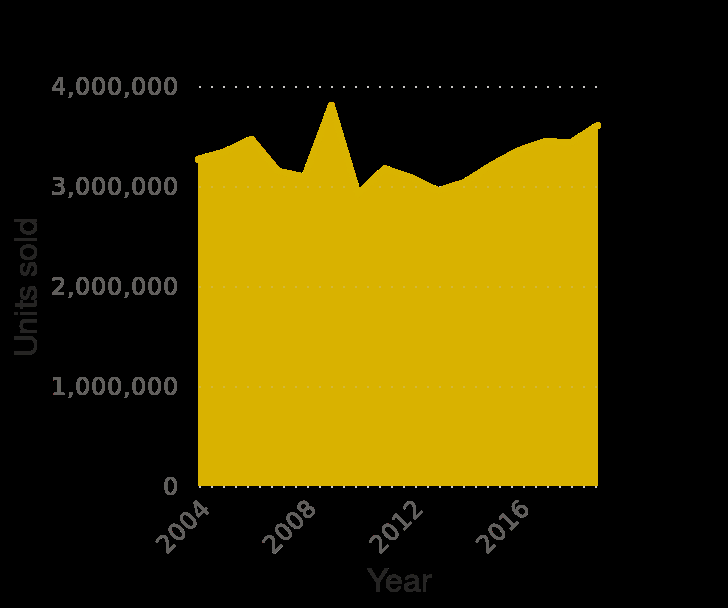<image>
What has been the trend in car sales since 2012?  There has been a continued increase in the number of cars sold. Describe the following image in detail This is a area plot called Number of passenger cars sold in Germany from 2004 to 2019. The x-axis plots Year with linear scale with a minimum of 2004 and a maximum of 2018 while the y-axis measures Units sold as linear scale with a minimum of 0 and a maximum of 4,000,000. 